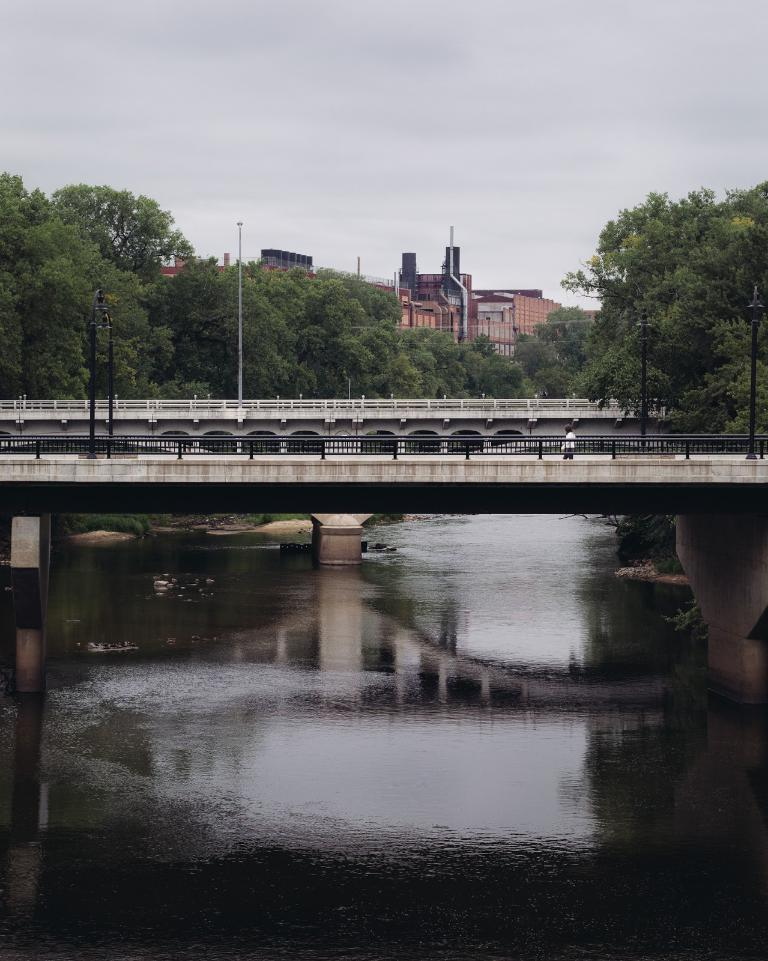What structure can be seen in the image? There is a bridge in the image. Who or what is on the bridge? There is a person on the bridge. What can be seen below the bridge? There is water visible in the image. What are the vertical supports in the image? There are poles in the image. What provides illumination in the image? There are lights in the image. What type of barrier is present in the image? There is fencing in the image. What type of vegetation is visible in the image? There are trees in the image. What type of man-made structures are visible in the image? There are buildings in the image. What part of the natural environment is visible in the image? The sky is visible in the image. What type of crate is being used to transport the tooth in the image? There is no crate or tooth present in the image. What level of difficulty is the person on the bridge experiencing in the image? The image does not provide any information about the person's level of difficulty or challenge. 